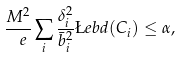Convert formula to latex. <formula><loc_0><loc_0><loc_500><loc_500>\frac { M ^ { 2 } } { \ e } \sum _ { i } \frac { \delta _ { i } ^ { 2 } } { \bar { b } _ { i } ^ { 2 } } \L e b { d } ( C _ { i } ) \leq \alpha ,</formula> 